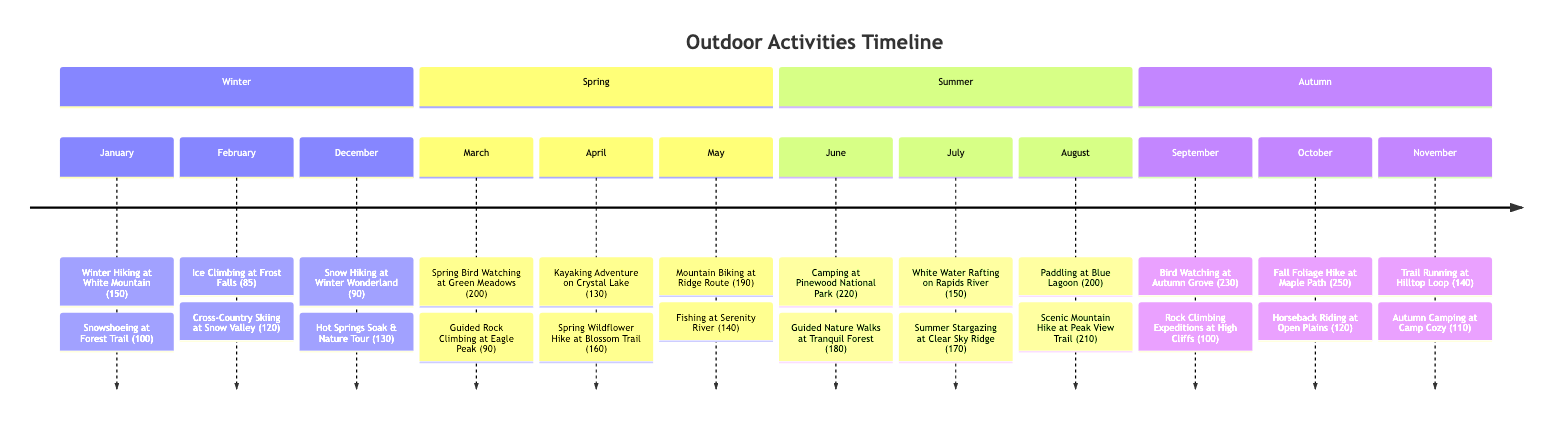What is the number of participants in the activity "Kayaking Adventure on Crystal Lake"? The diagram shows that for the month of April, the activity "Kayaking Adventure on Crystal Lake" has 130 participants listed next to it.
Answer: 130 Which activity had the highest participation in August? In the month of August, the activities listed are "Paddling at Blue Lagoon" with 200 participants and "Scenic Mountain Hike at Peak View Trail" with 210 participants. The latter has the highest participation.
Answer: Scenic Mountain Hike at Peak View Trail How many activities are listed for June? The timeline indicates that June has two activities: "Camping at Pinewood National Park" and "Guided Nature Walks at Tranquil Forest". Therefore, the total number of activities is 2.
Answer: 2 What is the total number of participants for September's activities? In September, there are two activities: "Bird Watching at Autumn Grove" with 230 participants and "Rock Climbing Expeditions at High Cliffs" with 100 participants. Adding these gives a total of 330 participants.
Answer: 330 Which month had more participants, October or November? For October, the activities are "Fall Foliage Hike at Maple Path" with 250 participants and "Horseback Riding at Open Plains" with 120 participants, totaling 370 participants. For November, "Trail Running at Hilltop Loop" has 140 participants and "Autumn Camping at Camp Cozy" has 110, totaling 250 participants. October has more participants.
Answer: October What is the average number of participants per activity in July? In July, there are two activities: "White Water Rafting on Rapids River" with 150 participants and "Summer Stargazing at Clear Sky Ridge" with 170 participants. The total participants is 320, divided by 2 activities gives an average of 160 participants per activity.
Answer: 160 Which season had the most participants in winter activities? In winter months (December, January, February), January has two activities totaling 250 participants (150 + 100), February has 205 participants (85 + 120), and December has 220 (90 + 130). January had the most participants.
Answer: January How many participants engaged in activities during the spring season? The spring months are March, April, and May. In March, the total is 290 participants (200 + 90), April is 290 (130 + 160), and May is 330 (190 + 140). Adding these totals gives 910 participants engaged in spring activities.
Answer: 910 